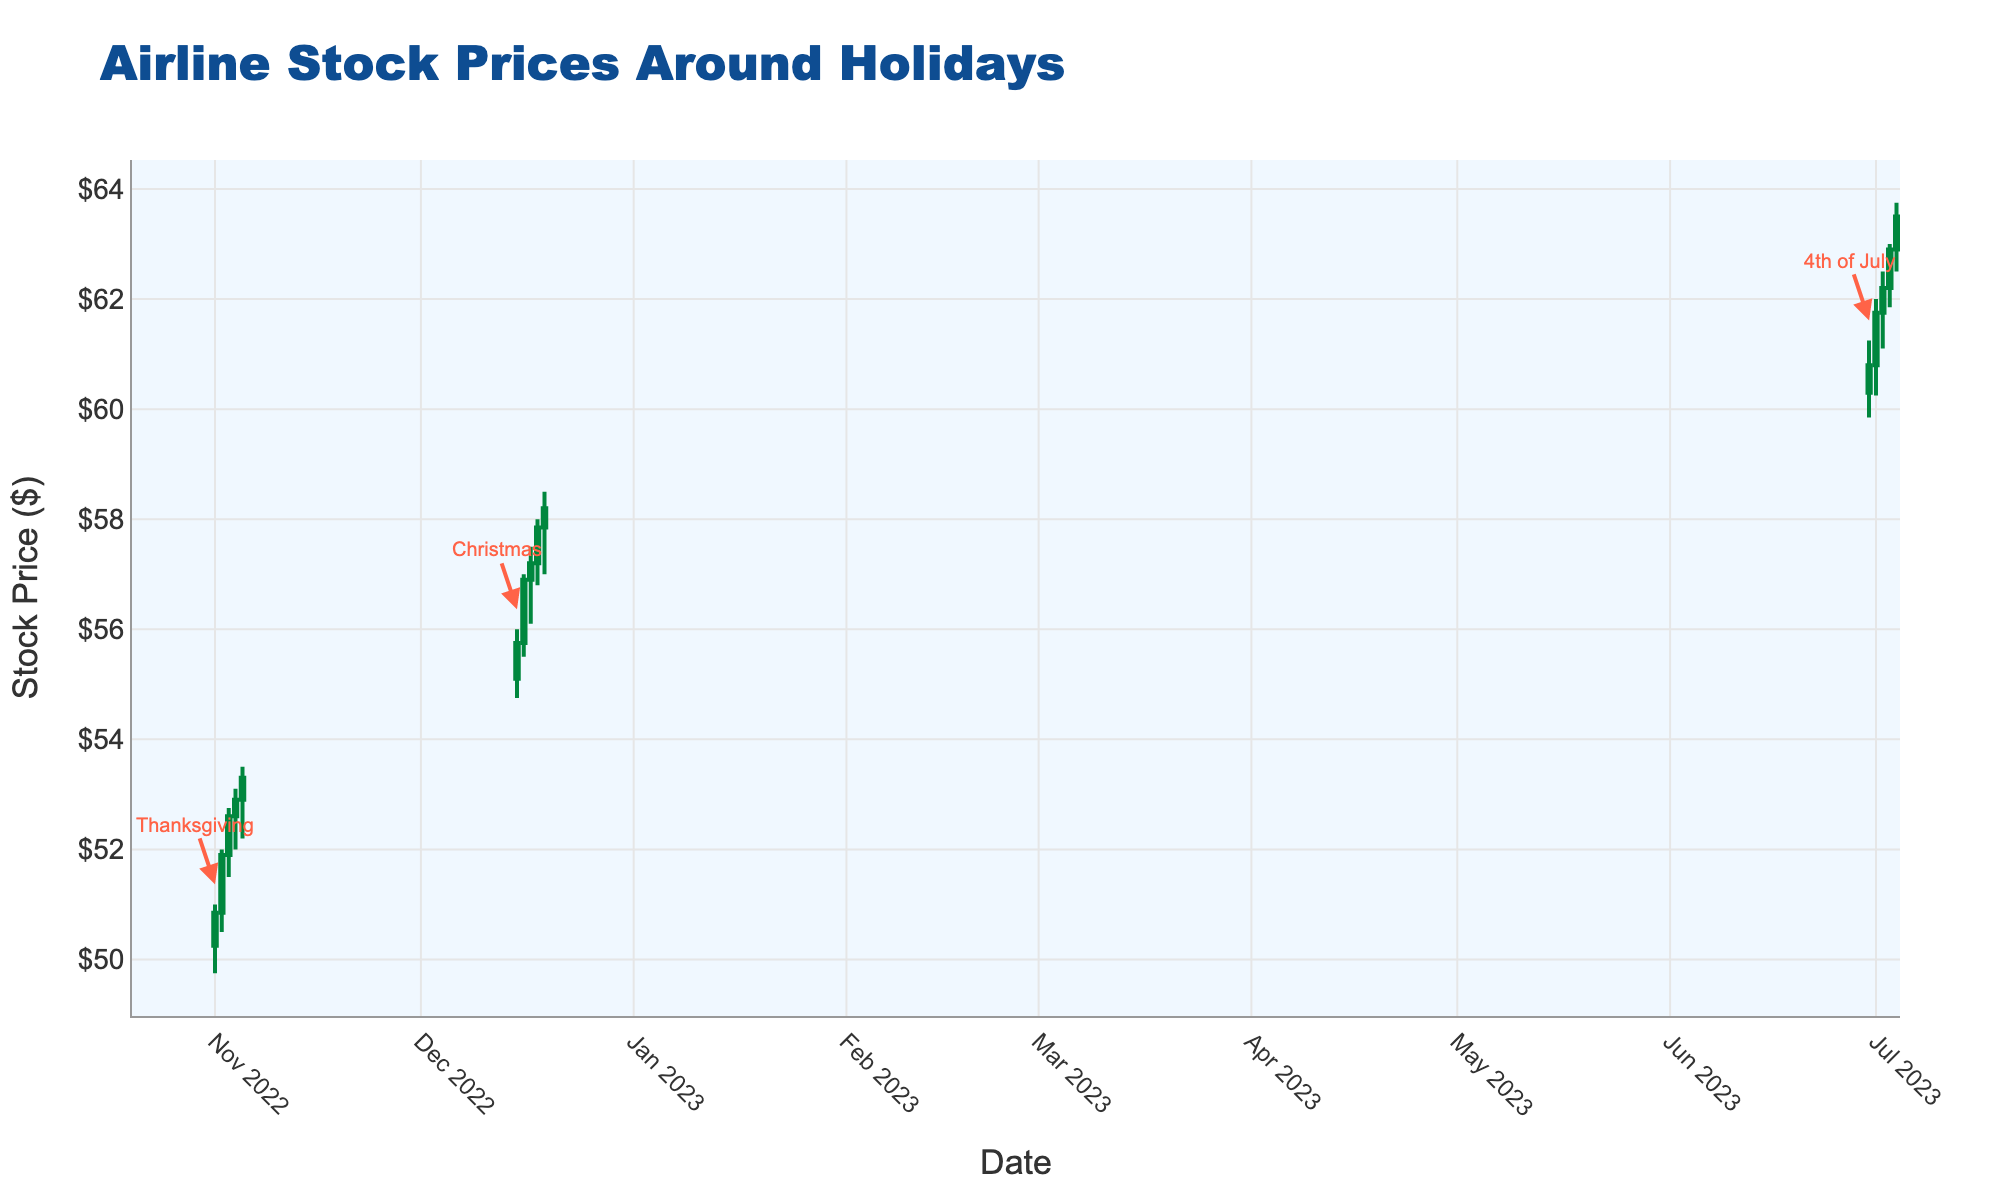When does the chart title indicate the data is about? The title of the chart is "Airline Stock Prices Around Holidays," which indicates that the data shown relates to stock prices of airlines during holiday periods.
Answer: Airline Stock Prices Around Holidays What is the price range for the airline stock on November 1st, 2022? The candlestick for November 1, 2022, shows the high price at $51.00 and the low price at $49.75, which gives the price range.
Answer: $49.75 to $51.00 Which holiday has the highest trading volume shown on the chart? By examining the candlesticks and the volume bars for each holiday period, we see the highest volume occurred during the 4th of July on July 4, 2023, with a volume of 1,850,000 shares.
Answer: 4th of July How does the stock price trend appear around Christmas as compared to Thanksgiving? The stock prices during Christmas (December 15-19, 2022) show an upward trend, while Thanksgiving (November 1-5, 2022) also shows a rising trend, but the Christmas period exhibits higher overall price levels.
Answer: Higher prices and stronger upward trend during Christmas What is the average closing price for the stock during the 4th of July holiday? To find the average, add the closing prices from June 30 to July 4, 2023 ($60.80, $61.75, $62.20, $62.90, $63.50), then divide by the number of days (5): (60.80 + 61.75 + 62.20 + 62.90 + 63.50) / 5 = 62.23.
Answer: $62.23 Which day saw the largest increase in stock price from open to close, and by how much? By examining the candlesticks, find the largest difference between open and close prices. December 16, 2022, saw the largest increase with the stock opening at $55.75 and closing at $56.90, an increase of $1.15.
Answer: December 16, 2022, $1.15 Is there a correlation between trading volume and stock price trends around holidays? By observing the candlesticks and volume bars, there appears to be a positive correlation, as higher trading volumes often coincide with increasing stock prices around the holidays.
Answer: Positive correlation What was the highest stock price during the Christmas holiday period? The highest price during the Christmas holiday period (December 15-19, 2022) is observed on December 19, 2022, at $58.50.
Answer: $58.50 How many days in total are displayed in the chart? Counting the individual days for each holiday period shown in the chart, there are 15 days in total.
Answer: 15 days 